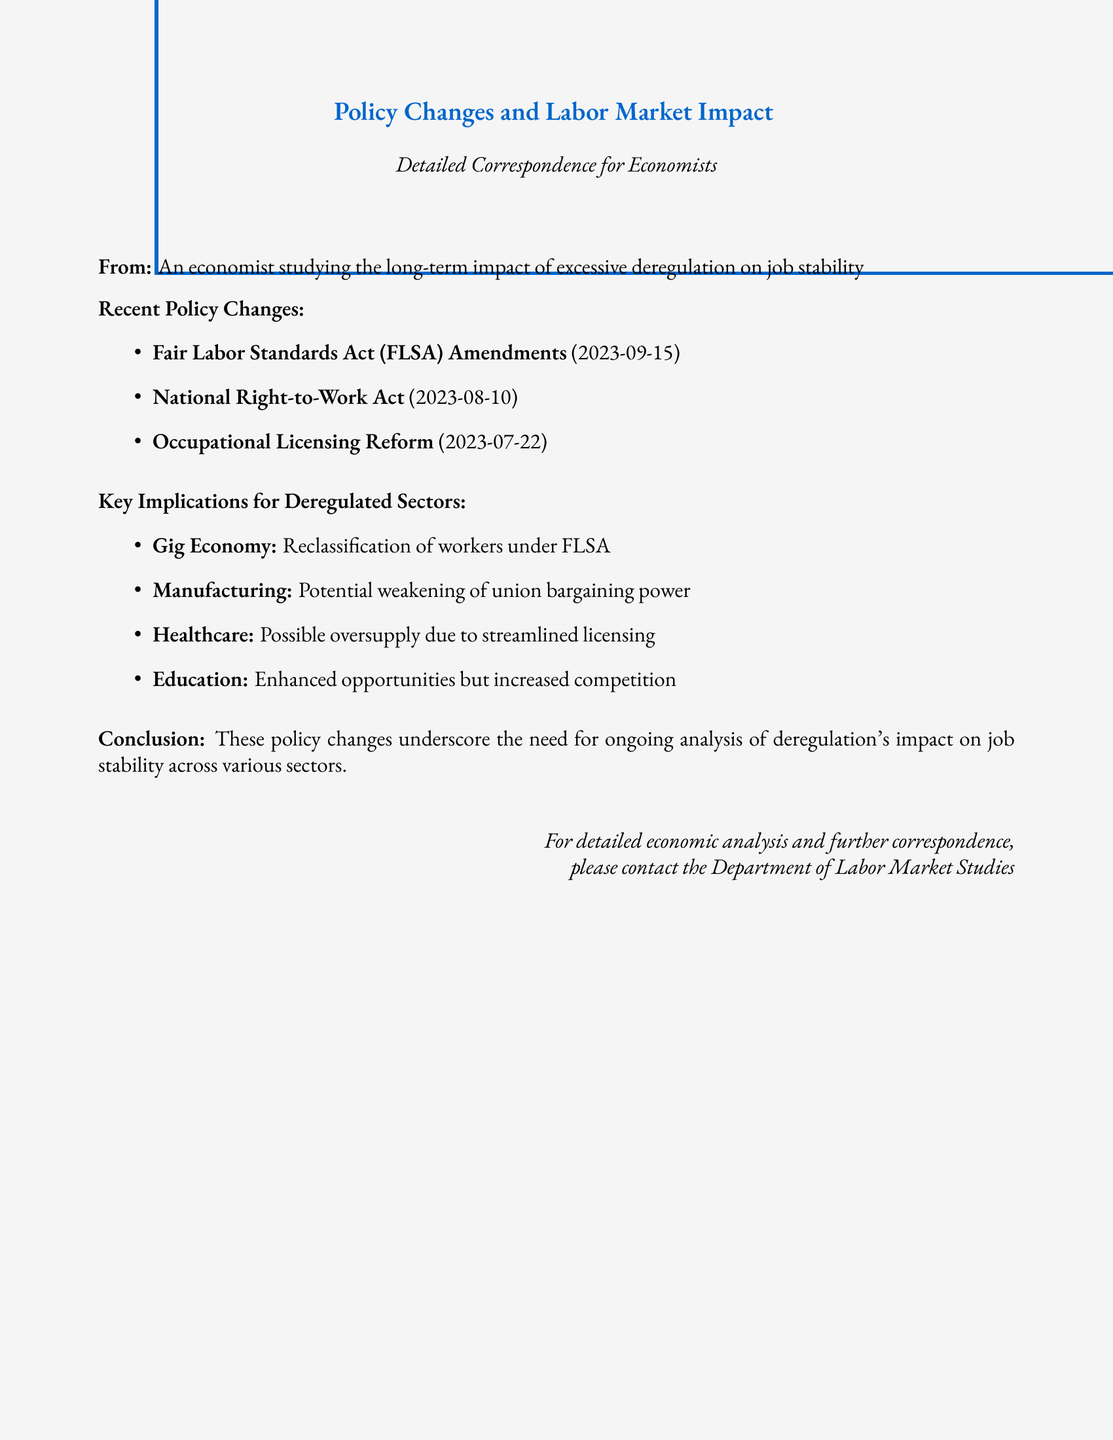What are the recent policy changes? The document lists three recent policy changes that impact labor markets: the Fair Labor Standards Act Amendments, the National Right-to-Work Act, and Occupational Licensing Reform.
Answer: Fair Labor Standards Act Amendments, National Right-to-Work Act, Occupational Licensing Reform When was the National Right-to-Work Act amended? The document specifies the date of the National Right-to-Work Act amendment as August 10, 2023.
Answer: 2023-08-10 What sector may experience increased competition due to policy changes? The document highlights the education sector as one that will face enhanced opportunities but increased competition due to the new policy changes.
Answer: Education What is a potential consequence of the FLSA amendments for the gig economy? The document indicates that a key implication for the gig economy is the reclassification of workers under the Fair Labor Standards Act.
Answer: Reclassification of workers What is the possible impact of licensing reform on the healthcare sector? According to the document, the streamlined licensing could lead to a possible oversupply in the healthcare sector.
Answer: Possible oversupply What does the document suggest about union bargaining power in manufacturing? The document suggests that there may be a potential weakening of union bargaining power in the manufacturing sector as a result of recent policy changes.
Answer: Potential weakening of union bargaining power What is the conclusion stated in the document? The document concludes that the policy changes highlight the necessity for ongoing analysis of deregulation's impact on job stability in various sectors.
Answer: Ongoing analysis of deregulation's impact on job stability Who can be contacted for further correspondence? The document states that the Department of Labor Market Studies is available for detailed economic analysis and further correspondence.
Answer: Department of Labor Market Studies 